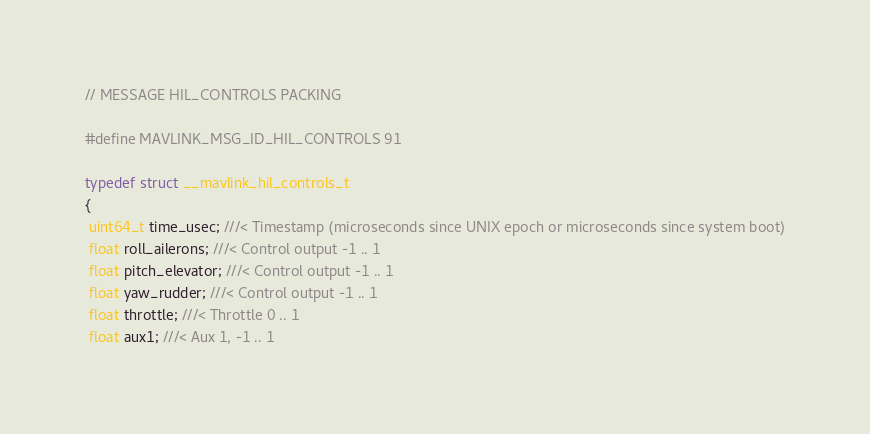Convert code to text. <code><loc_0><loc_0><loc_500><loc_500><_C_>// MESSAGE HIL_CONTROLS PACKING

#define MAVLINK_MSG_ID_HIL_CONTROLS 91

typedef struct __mavlink_hil_controls_t
{
 uint64_t time_usec; ///< Timestamp (microseconds since UNIX epoch or microseconds since system boot)
 float roll_ailerons; ///< Control output -1 .. 1
 float pitch_elevator; ///< Control output -1 .. 1
 float yaw_rudder; ///< Control output -1 .. 1
 float throttle; ///< Throttle 0 .. 1
 float aux1; ///< Aux 1, -1 .. 1</code> 